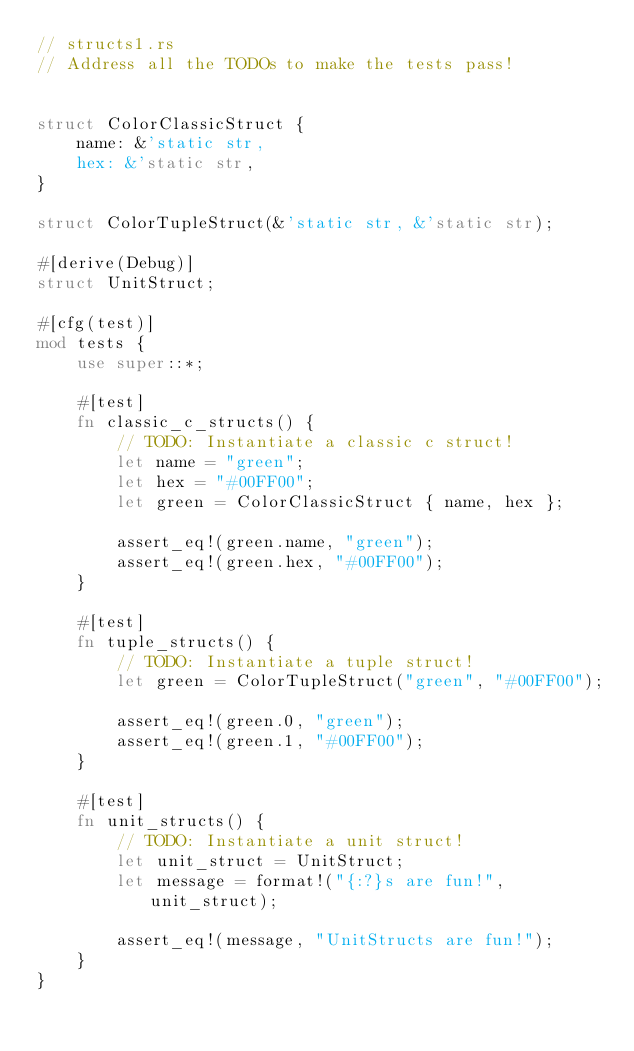Convert code to text. <code><loc_0><loc_0><loc_500><loc_500><_Rust_>// structs1.rs
// Address all the TODOs to make the tests pass!


struct ColorClassicStruct {
    name: &'static str,
    hex: &'static str,
}

struct ColorTupleStruct(&'static str, &'static str);

#[derive(Debug)]
struct UnitStruct;

#[cfg(test)]
mod tests {
    use super::*;

    #[test]
    fn classic_c_structs() {
        // TODO: Instantiate a classic c struct!
        let name = "green";
        let hex = "#00FF00";
        let green = ColorClassicStruct { name, hex };

        assert_eq!(green.name, "green");
        assert_eq!(green.hex, "#00FF00");
    }

    #[test]
    fn tuple_structs() {
        // TODO: Instantiate a tuple struct!
        let green = ColorTupleStruct("green", "#00FF00");

        assert_eq!(green.0, "green");
        assert_eq!(green.1, "#00FF00");
    }

    #[test]
    fn unit_structs() {
        // TODO: Instantiate a unit struct!
        let unit_struct = UnitStruct;
        let message = format!("{:?}s are fun!", unit_struct);

        assert_eq!(message, "UnitStructs are fun!");
    }
}
</code> 